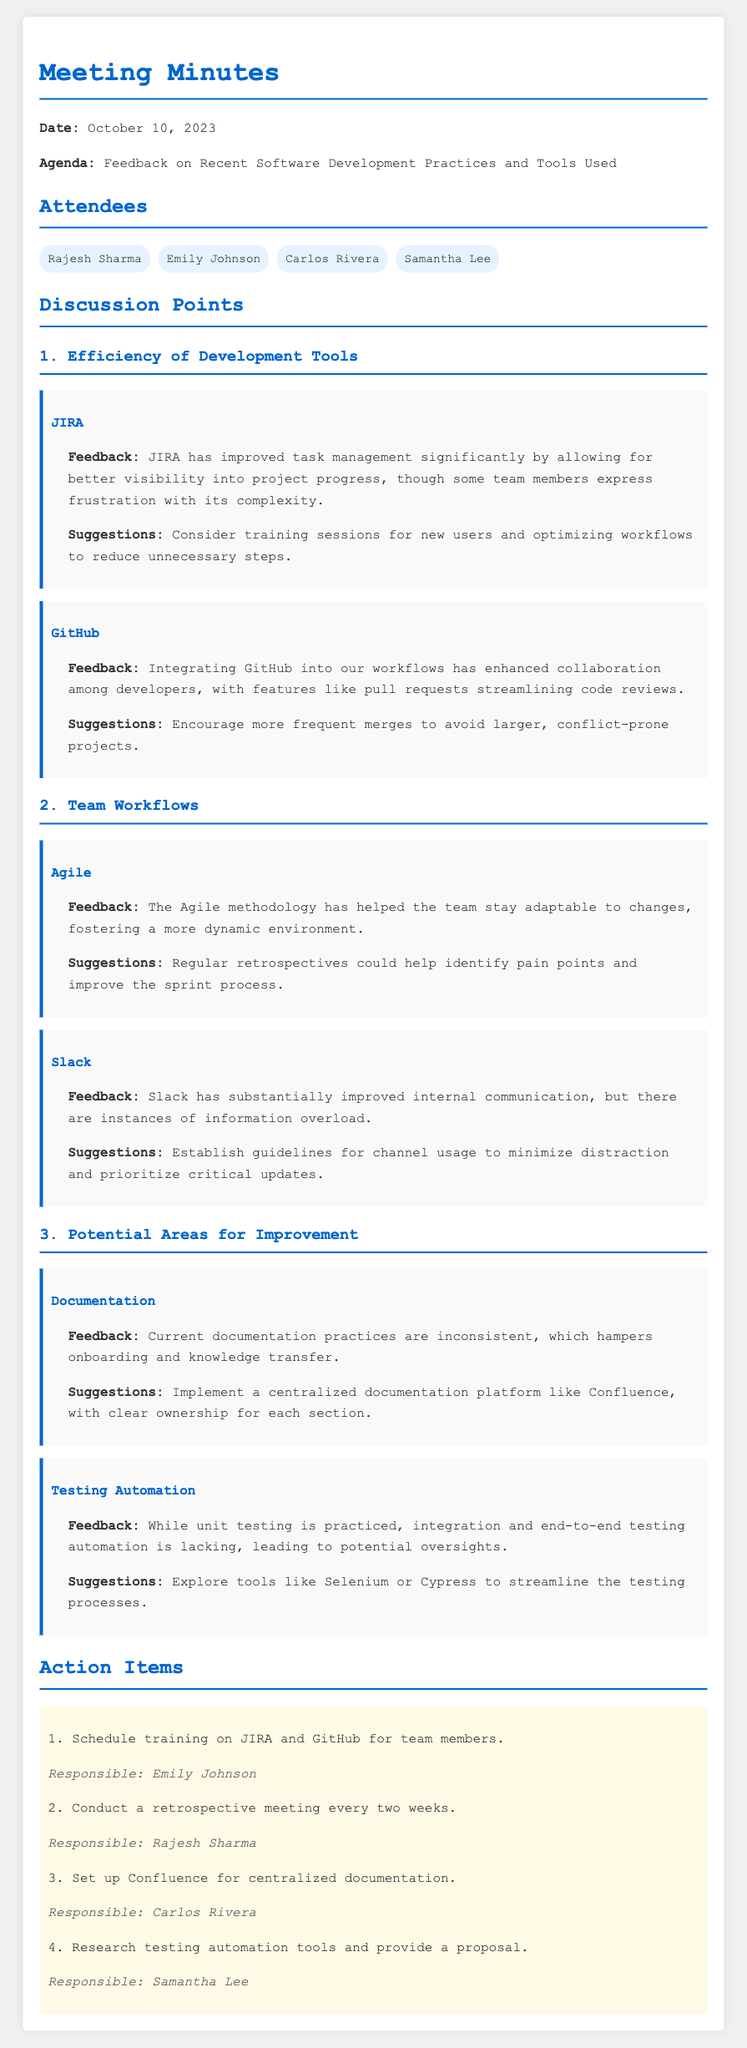What was the date of the meeting? The date of the meeting is mentioned in the introduction of the document.
Answer: October 10, 2023 Who is responsible for scheduling the training on JIRA and GitHub? The action items section lists the responsible individuals for each task.
Answer: Emily Johnson What feedback was provided about JIRA? The feedback section for JIRA outlines the team's opinions about this tool.
Answer: Improved task management significantly but frustratingly complex What tool is suggested for centralized documentation? The suggestions for improvement point out a specific tool that can aid documentation.
Answer: Confluence How often should the retrospective meeting be conducted? The action items include a specific frequency for these meetings.
Answer: Every two weeks What issue was highlighted regarding documentation practices? The feedback section identifies a significant problem concerning documentation.
Answer: Inconsistent documentation practices What has enhanced collaboration among developers? The feedback section describes a tool that promotes teamwork.
Answer: GitHub What is one suggestion for improving Slack usage? The suggestions related to Slack provide a specific recommendation.
Answer: Establish guidelines for channel usage What testing aspects are lacking according to the document? The feedback on testing mentions particular types that need improvement.
Answer: Integration and end-to-end testing automation 